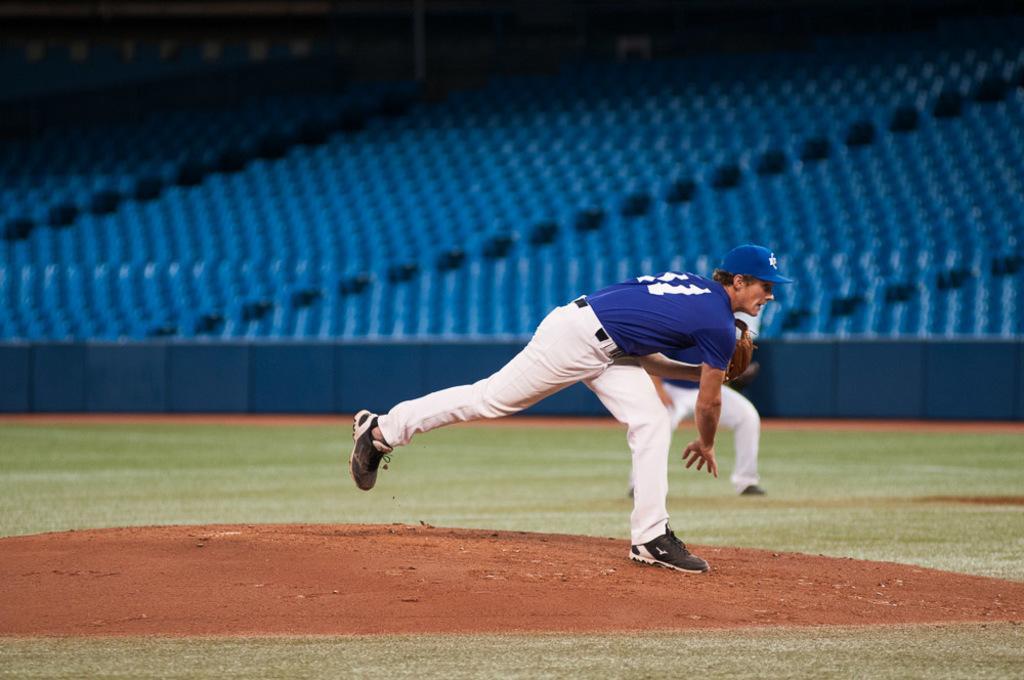In one or two sentences, can you explain what this image depicts? This image is taken in a playground. In this image we can see two persons. In the background we can see chairs. We can also see a blue color fence. 